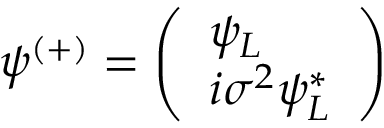<formula> <loc_0><loc_0><loc_500><loc_500>\psi ^ { ( + ) } = { \left ( \begin{array} { l } { \psi _ { L } } \\ { i \sigma ^ { 2 } \psi _ { L } ^ { * } } \end{array} \right ) }</formula> 